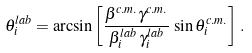<formula> <loc_0><loc_0><loc_500><loc_500>\theta _ { i } ^ { l a b } = \arcsin \left [ \frac { \beta ^ { c . m . } \gamma ^ { c . m . } } { \beta _ { i } ^ { l a b } \, \gamma _ { i } ^ { l a b } } \, \sin \theta _ { i } ^ { c . m . } \right ] \, .</formula> 